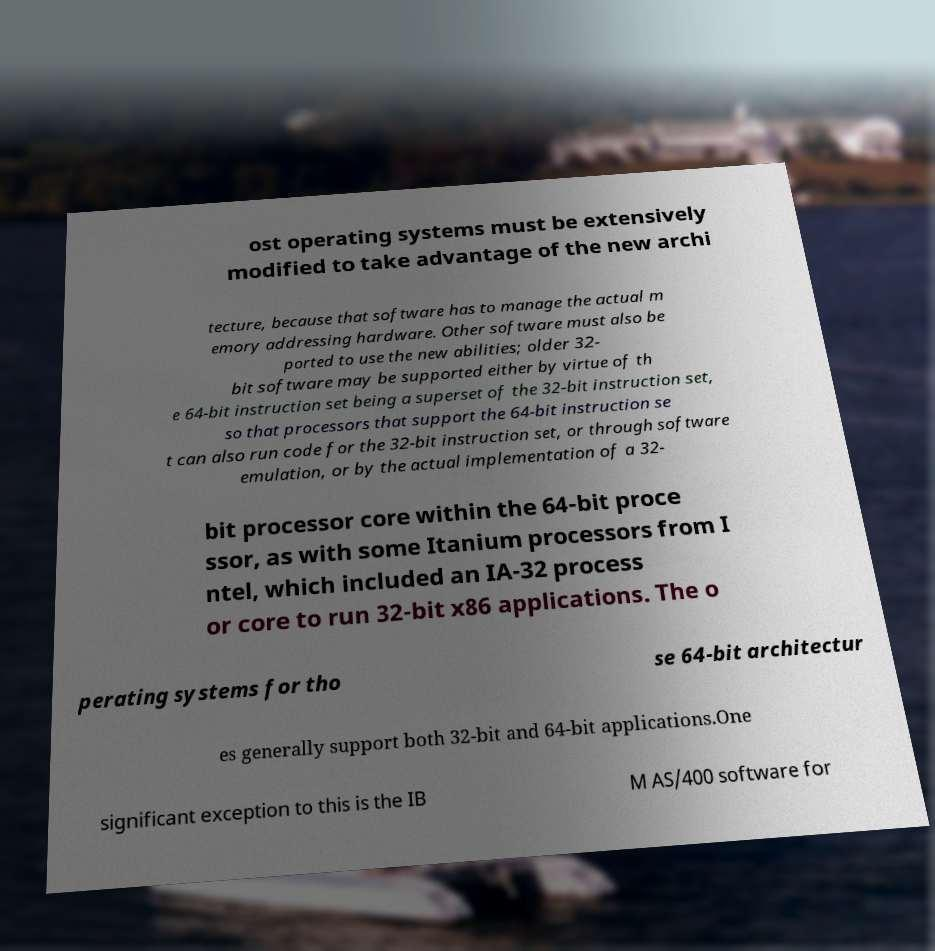There's text embedded in this image that I need extracted. Can you transcribe it verbatim? ost operating systems must be extensively modified to take advantage of the new archi tecture, because that software has to manage the actual m emory addressing hardware. Other software must also be ported to use the new abilities; older 32- bit software may be supported either by virtue of th e 64-bit instruction set being a superset of the 32-bit instruction set, so that processors that support the 64-bit instruction se t can also run code for the 32-bit instruction set, or through software emulation, or by the actual implementation of a 32- bit processor core within the 64-bit proce ssor, as with some Itanium processors from I ntel, which included an IA-32 process or core to run 32-bit x86 applications. The o perating systems for tho se 64-bit architectur es generally support both 32-bit and 64-bit applications.One significant exception to this is the IB M AS/400 software for 